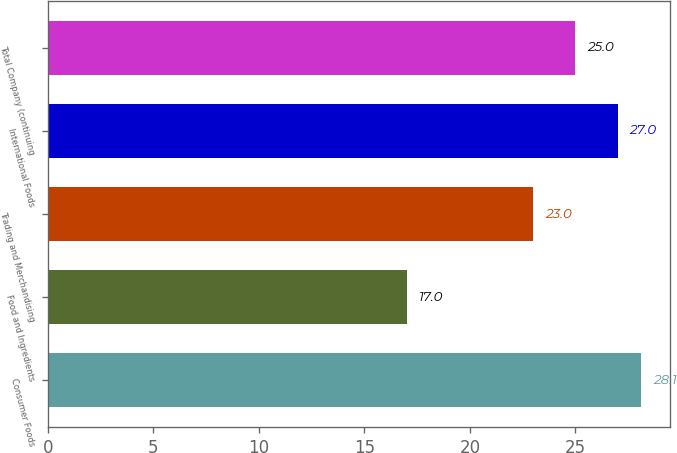Convert chart to OTSL. <chart><loc_0><loc_0><loc_500><loc_500><bar_chart><fcel>Consumer Foods<fcel>Food and Ingredients<fcel>Trading and Merchandising<fcel>International Foods<fcel>Total Company (continuing<nl><fcel>28.1<fcel>17<fcel>23<fcel>27<fcel>25<nl></chart> 